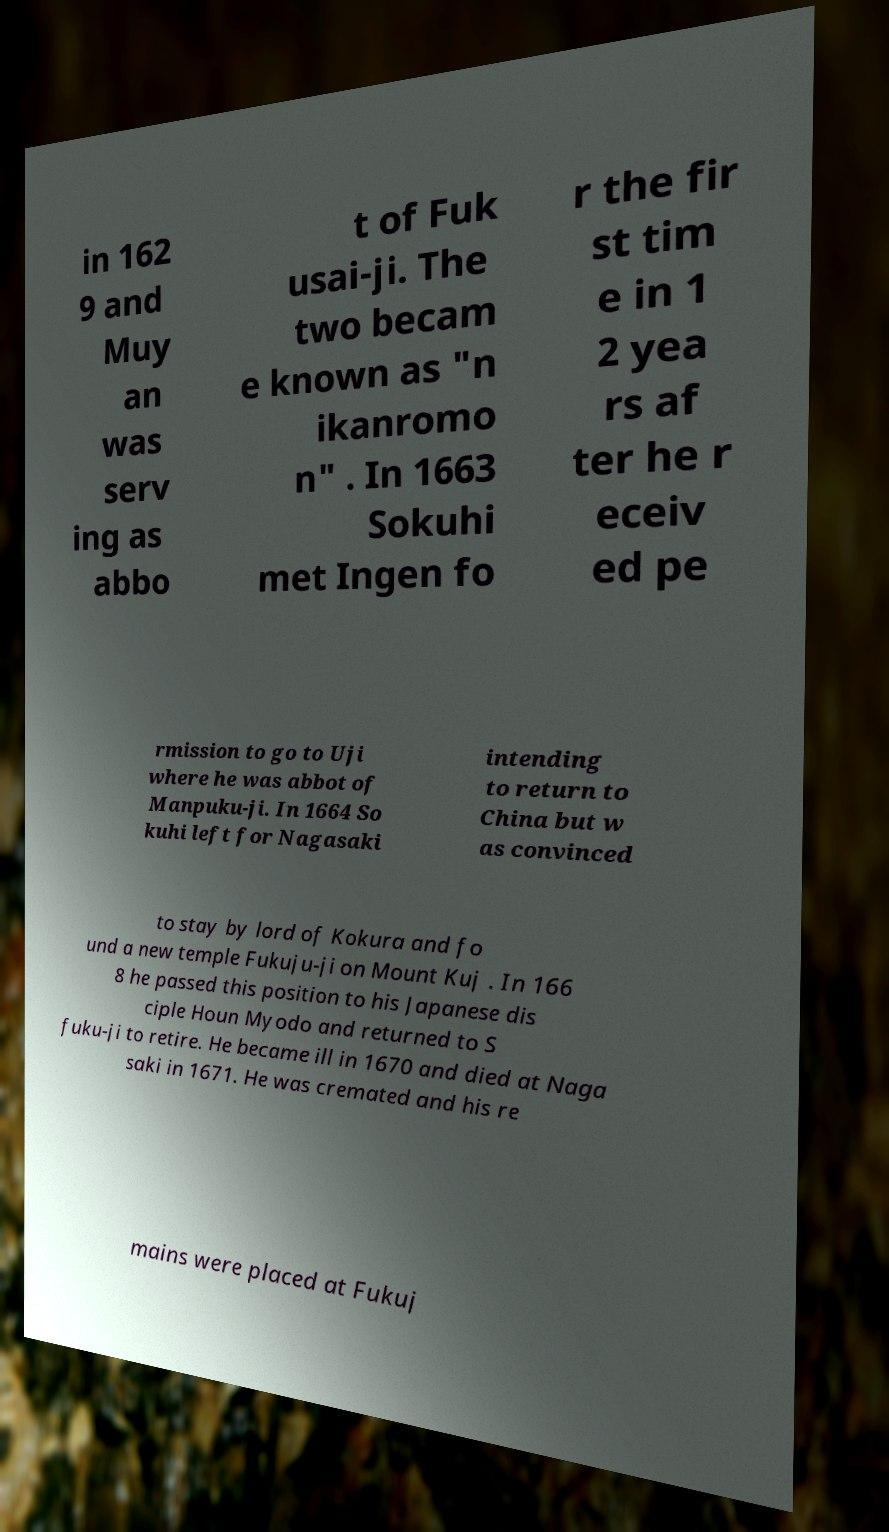Please read and relay the text visible in this image. What does it say? in 162 9 and Muy an was serv ing as abbo t of Fuk usai-ji. The two becam e known as "n ikanromo n" . In 1663 Sokuhi met Ingen fo r the fir st tim e in 1 2 yea rs af ter he r eceiv ed pe rmission to go to Uji where he was abbot of Manpuku-ji. In 1664 So kuhi left for Nagasaki intending to return to China but w as convinced to stay by lord of Kokura and fo und a new temple Fukuju-ji on Mount Kuj . In 166 8 he passed this position to his Japanese dis ciple Houn Myodo and returned to S fuku-ji to retire. He became ill in 1670 and died at Naga saki in 1671. He was cremated and his re mains were placed at Fukuj 